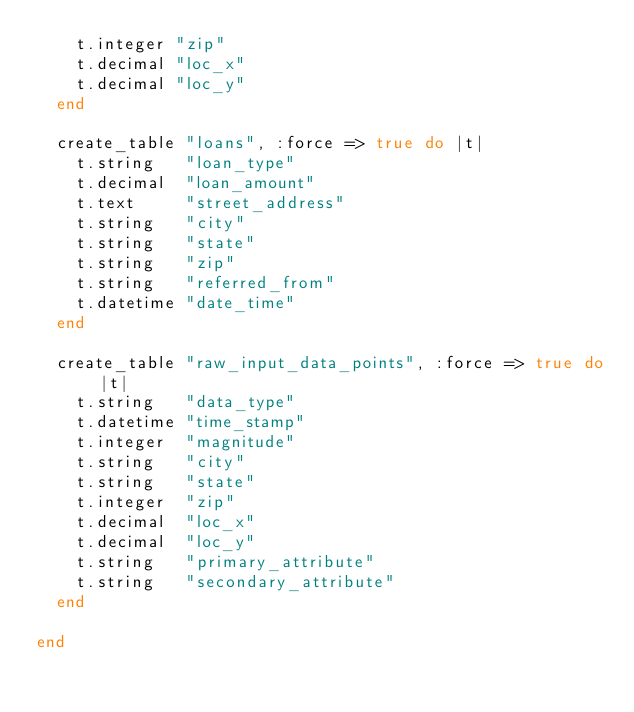<code> <loc_0><loc_0><loc_500><loc_500><_Ruby_>    t.integer "zip"
    t.decimal "loc_x"
    t.decimal "loc_y"
  end

  create_table "loans", :force => true do |t|
    t.string   "loan_type"
    t.decimal  "loan_amount"
    t.text     "street_address"
    t.string   "city"
    t.string   "state"
    t.string   "zip"
    t.string   "referred_from"
    t.datetime "date_time"
  end

  create_table "raw_input_data_points", :force => true do |t|
    t.string   "data_type"
    t.datetime "time_stamp"
    t.integer  "magnitude"
    t.string   "city"
    t.string   "state"
    t.integer  "zip"
    t.decimal  "loc_x"
    t.decimal  "loc_y"
    t.string   "primary_attribute"
    t.string   "secondary_attribute"
  end

end
</code> 